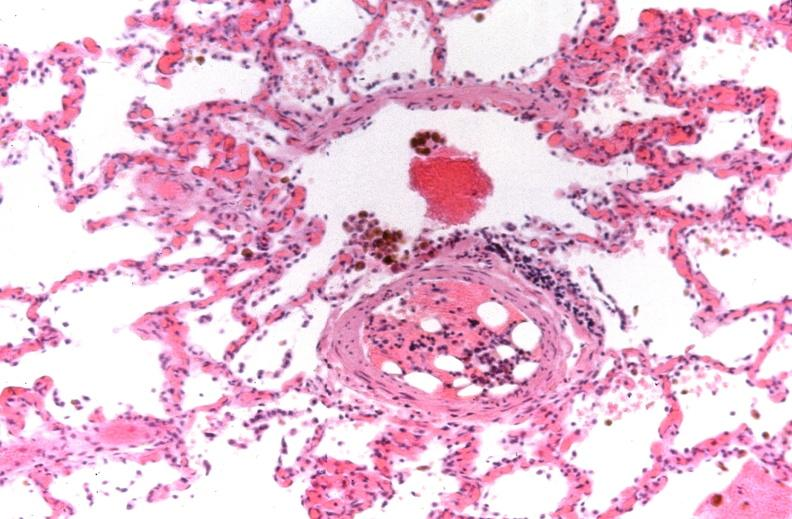does this image show lung, congestive heart failure, bone marrow embolus?
Answer the question using a single word or phrase. Yes 